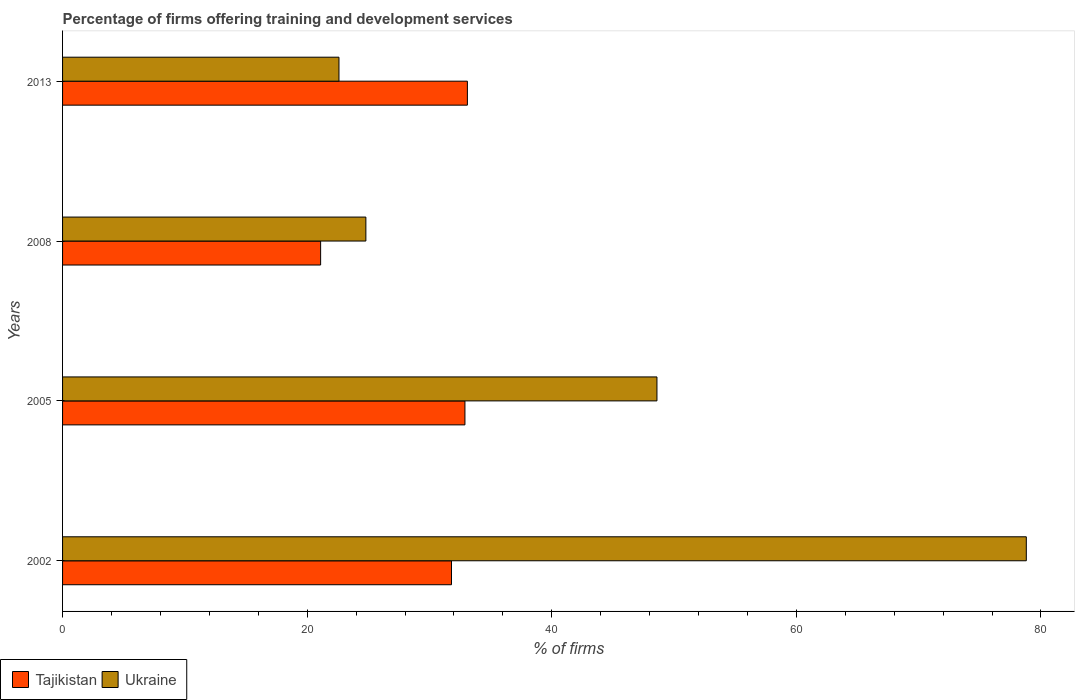Are the number of bars on each tick of the Y-axis equal?
Ensure brevity in your answer.  Yes. How many bars are there on the 2nd tick from the bottom?
Your response must be concise. 2. What is the percentage of firms offering training and development in Ukraine in 2002?
Give a very brief answer. 78.8. Across all years, what is the maximum percentage of firms offering training and development in Tajikistan?
Your answer should be compact. 33.1. Across all years, what is the minimum percentage of firms offering training and development in Ukraine?
Give a very brief answer. 22.6. In which year was the percentage of firms offering training and development in Tajikistan minimum?
Your answer should be very brief. 2008. What is the total percentage of firms offering training and development in Ukraine in the graph?
Offer a very short reply. 174.8. What is the difference between the percentage of firms offering training and development in Tajikistan in 2002 and that in 2005?
Offer a terse response. -1.1. What is the difference between the percentage of firms offering training and development in Tajikistan in 2013 and the percentage of firms offering training and development in Ukraine in 2002?
Provide a succinct answer. -45.7. What is the average percentage of firms offering training and development in Ukraine per year?
Your answer should be compact. 43.7. In how many years, is the percentage of firms offering training and development in Tajikistan greater than 68 %?
Offer a terse response. 0. What is the ratio of the percentage of firms offering training and development in Tajikistan in 2005 to that in 2013?
Give a very brief answer. 0.99. Is the percentage of firms offering training and development in Ukraine in 2002 less than that in 2005?
Offer a terse response. No. Is the difference between the percentage of firms offering training and development in Tajikistan in 2005 and 2013 greater than the difference between the percentage of firms offering training and development in Ukraine in 2005 and 2013?
Give a very brief answer. No. What is the difference between the highest and the second highest percentage of firms offering training and development in Tajikistan?
Offer a terse response. 0.2. What does the 2nd bar from the top in 2002 represents?
Give a very brief answer. Tajikistan. What does the 2nd bar from the bottom in 2005 represents?
Provide a short and direct response. Ukraine. Are all the bars in the graph horizontal?
Provide a succinct answer. Yes. How many years are there in the graph?
Keep it short and to the point. 4. Does the graph contain any zero values?
Offer a very short reply. No. How are the legend labels stacked?
Offer a very short reply. Horizontal. What is the title of the graph?
Provide a short and direct response. Percentage of firms offering training and development services. What is the label or title of the X-axis?
Ensure brevity in your answer.  % of firms. What is the label or title of the Y-axis?
Make the answer very short. Years. What is the % of firms in Tajikistan in 2002?
Your response must be concise. 31.8. What is the % of firms of Ukraine in 2002?
Provide a short and direct response. 78.8. What is the % of firms of Tajikistan in 2005?
Offer a terse response. 32.9. What is the % of firms of Ukraine in 2005?
Your answer should be compact. 48.6. What is the % of firms in Tajikistan in 2008?
Your answer should be compact. 21.1. What is the % of firms of Ukraine in 2008?
Your answer should be very brief. 24.8. What is the % of firms in Tajikistan in 2013?
Your answer should be compact. 33.1. What is the % of firms in Ukraine in 2013?
Give a very brief answer. 22.6. Across all years, what is the maximum % of firms in Tajikistan?
Your answer should be very brief. 33.1. Across all years, what is the maximum % of firms in Ukraine?
Provide a succinct answer. 78.8. Across all years, what is the minimum % of firms of Tajikistan?
Your answer should be very brief. 21.1. Across all years, what is the minimum % of firms in Ukraine?
Your answer should be very brief. 22.6. What is the total % of firms of Tajikistan in the graph?
Keep it short and to the point. 118.9. What is the total % of firms of Ukraine in the graph?
Provide a succinct answer. 174.8. What is the difference between the % of firms in Ukraine in 2002 and that in 2005?
Provide a short and direct response. 30.2. What is the difference between the % of firms of Ukraine in 2002 and that in 2013?
Offer a terse response. 56.2. What is the difference between the % of firms of Tajikistan in 2005 and that in 2008?
Keep it short and to the point. 11.8. What is the difference between the % of firms of Ukraine in 2005 and that in 2008?
Offer a terse response. 23.8. What is the difference between the % of firms in Ukraine in 2005 and that in 2013?
Offer a terse response. 26. What is the difference between the % of firms in Tajikistan in 2008 and that in 2013?
Your response must be concise. -12. What is the difference between the % of firms of Tajikistan in 2002 and the % of firms of Ukraine in 2005?
Offer a very short reply. -16.8. What is the difference between the % of firms in Tajikistan in 2002 and the % of firms in Ukraine in 2008?
Offer a terse response. 7. What is the difference between the % of firms in Tajikistan in 2005 and the % of firms in Ukraine in 2008?
Keep it short and to the point. 8.1. What is the difference between the % of firms in Tajikistan in 2005 and the % of firms in Ukraine in 2013?
Your answer should be compact. 10.3. What is the average % of firms in Tajikistan per year?
Provide a succinct answer. 29.73. What is the average % of firms in Ukraine per year?
Offer a terse response. 43.7. In the year 2002, what is the difference between the % of firms in Tajikistan and % of firms in Ukraine?
Keep it short and to the point. -47. In the year 2005, what is the difference between the % of firms in Tajikistan and % of firms in Ukraine?
Your answer should be compact. -15.7. In the year 2008, what is the difference between the % of firms in Tajikistan and % of firms in Ukraine?
Provide a succinct answer. -3.7. In the year 2013, what is the difference between the % of firms of Tajikistan and % of firms of Ukraine?
Provide a short and direct response. 10.5. What is the ratio of the % of firms of Tajikistan in 2002 to that in 2005?
Offer a terse response. 0.97. What is the ratio of the % of firms of Ukraine in 2002 to that in 2005?
Give a very brief answer. 1.62. What is the ratio of the % of firms of Tajikistan in 2002 to that in 2008?
Offer a very short reply. 1.51. What is the ratio of the % of firms in Ukraine in 2002 to that in 2008?
Make the answer very short. 3.18. What is the ratio of the % of firms in Tajikistan in 2002 to that in 2013?
Provide a succinct answer. 0.96. What is the ratio of the % of firms in Ukraine in 2002 to that in 2013?
Your answer should be very brief. 3.49. What is the ratio of the % of firms in Tajikistan in 2005 to that in 2008?
Make the answer very short. 1.56. What is the ratio of the % of firms in Ukraine in 2005 to that in 2008?
Provide a succinct answer. 1.96. What is the ratio of the % of firms in Tajikistan in 2005 to that in 2013?
Provide a short and direct response. 0.99. What is the ratio of the % of firms in Ukraine in 2005 to that in 2013?
Your response must be concise. 2.15. What is the ratio of the % of firms in Tajikistan in 2008 to that in 2013?
Offer a very short reply. 0.64. What is the ratio of the % of firms of Ukraine in 2008 to that in 2013?
Give a very brief answer. 1.1. What is the difference between the highest and the second highest % of firms in Ukraine?
Offer a terse response. 30.2. What is the difference between the highest and the lowest % of firms in Tajikistan?
Provide a succinct answer. 12. What is the difference between the highest and the lowest % of firms of Ukraine?
Your answer should be compact. 56.2. 